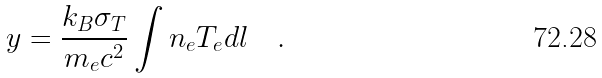Convert formula to latex. <formula><loc_0><loc_0><loc_500><loc_500>y = \frac { k _ { B } \sigma _ { T } } { m _ { e } c ^ { 2 } } \int n _ { e } T _ { e } d l \quad .</formula> 